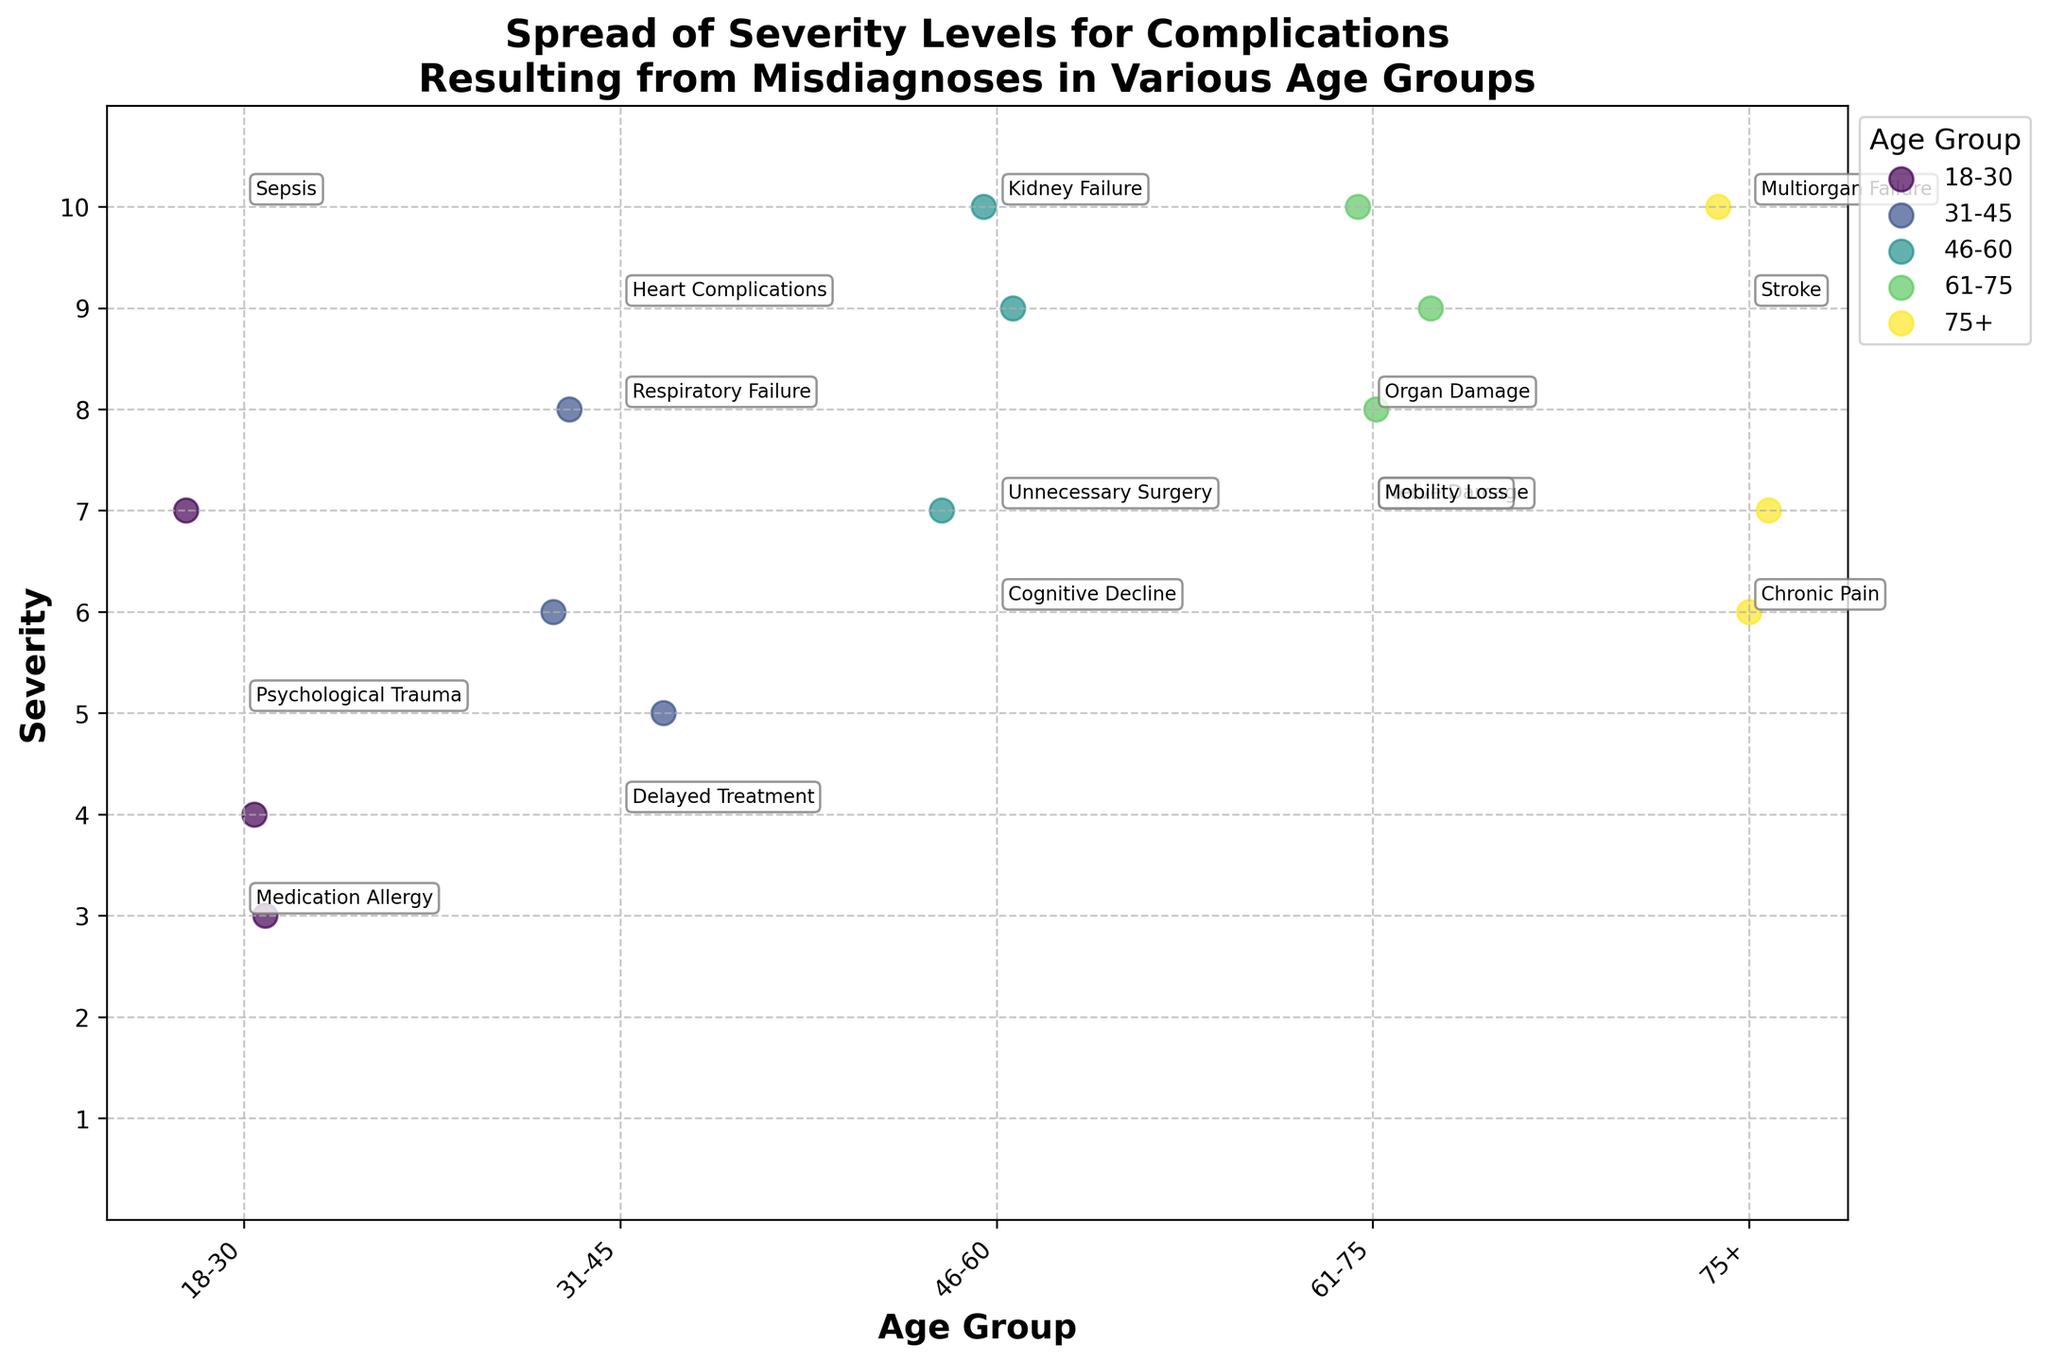What is the title of the figure? The title is prominently displayed at the top of the figure. It reads "Spread of Severity Levels for Complications Resulting from Misdiagnoses in Various Age Groups."
Answer: Spread of Severity Levels for Complications Resulting from Misdiagnoses in Various Age Groups What age group has the complication with the lowest severity level? To identify the age group with the lowest severity, look at the Y-axis for the minimum value point and then refer to the corresponding age group label on the X-axis. The closest minimum severity level dot is 3 in the 18-30 age group.
Answer: 18-30 Which age group has the most severe complications? Look for the highest value on the Y-axis, which is 10. Then identify the corresponding age groups on the X-axis. Both the 46-60 and 61-75 age groups contain complications with severity 10.
Answer: 46-60 and 61-75 How many severity levels are represented in the 31-45 age group? Count the dots above the age group label "31-45" along the X-axis. Each dot represents a severity level for a different complication. There are 3 dots.
Answer: 3 What type of complication has a severity level of 8 in the 31-45 age group? Find the dot labeled with a severity of 8 in the 31-45 age group and read the annotation next to it. The complication with severity 8 in this age group is Organ Damage.
Answer: Organ Damage Are there any complications with a severity level of 10 in the 75+ age group? Examine the dots above the "75+" label on the X-axis and check if any of them align with severity level 10 on the Y-axis. There is one dot at severity level 10.
Answer: Yes What is the average severity level of complications in the 46-60 age group? Identify the severity levels for the 46-60 age group (9, 10, 7). Sum them up (9 + 10 + 7 = 26) and divide by the number of complications, which is 3. The average severity is 26/3 ≈ 8.67.
Answer: 8.67 Which age group has the most diverse range of severity levels for complications? Compare the spread of dots along the Y-axis for each age group. The 46-60 and 61-75 age groups have severity levels ranging from 7 to 10, indicating a more diverse range compared to the other groups.
Answer: 46-60 and 61-75 What is the most common severity level for complications across all age groups? Observe the overall distribution of dots across all age groups to see which severity level along the Y-axis has the most dots. Severity levels of 7 and 10 appear most frequently.
Answer: 7 and 10 Which complications were annotated in the 75+ age group? Look at the annotations next to each dot in the 75+ age group on the X-axis. The annotated complications are Cognitive Decline, Mobility Loss, and Multiorgan Failure.
Answer: Cognitive Decline, Mobility Loss, Multiorgan Failure 